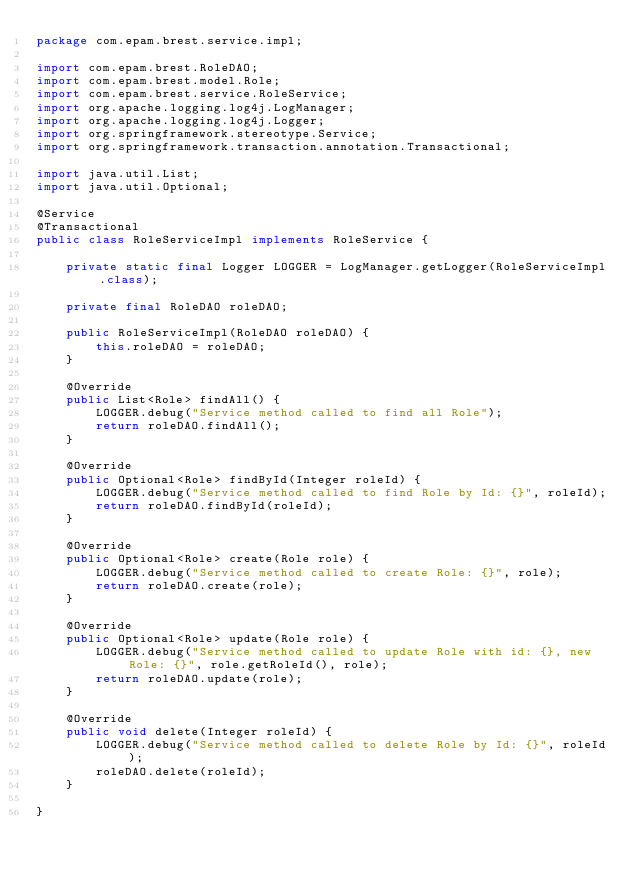<code> <loc_0><loc_0><loc_500><loc_500><_Java_>package com.epam.brest.service.impl;

import com.epam.brest.RoleDAO;
import com.epam.brest.model.Role;
import com.epam.brest.service.RoleService;
import org.apache.logging.log4j.LogManager;
import org.apache.logging.log4j.Logger;
import org.springframework.stereotype.Service;
import org.springframework.transaction.annotation.Transactional;

import java.util.List;
import java.util.Optional;

@Service
@Transactional
public class RoleServiceImpl implements RoleService {

    private static final Logger LOGGER = LogManager.getLogger(RoleServiceImpl.class);

    private final RoleDAO roleDAO;

    public RoleServiceImpl(RoleDAO roleDAO) {
        this.roleDAO = roleDAO;
    }

    @Override
    public List<Role> findAll() {
        LOGGER.debug("Service method called to find all Role");
        return roleDAO.findAll();
    }

    @Override
    public Optional<Role> findById(Integer roleId) {
        LOGGER.debug("Service method called to find Role by Id: {}", roleId);
        return roleDAO.findById(roleId);
    }

    @Override
    public Optional<Role> create(Role role) {
        LOGGER.debug("Service method called to create Role: {}", role);
        return roleDAO.create(role);
    }

    @Override
    public Optional<Role> update(Role role) {
        LOGGER.debug("Service method called to update Role with id: {}, new Role: {}", role.getRoleId(), role);
        return roleDAO.update(role);
    }

    @Override
    public void delete(Integer roleId) {
        LOGGER.debug("Service method called to delete Role by Id: {}", roleId);
        roleDAO.delete(roleId);
    }

}
</code> 